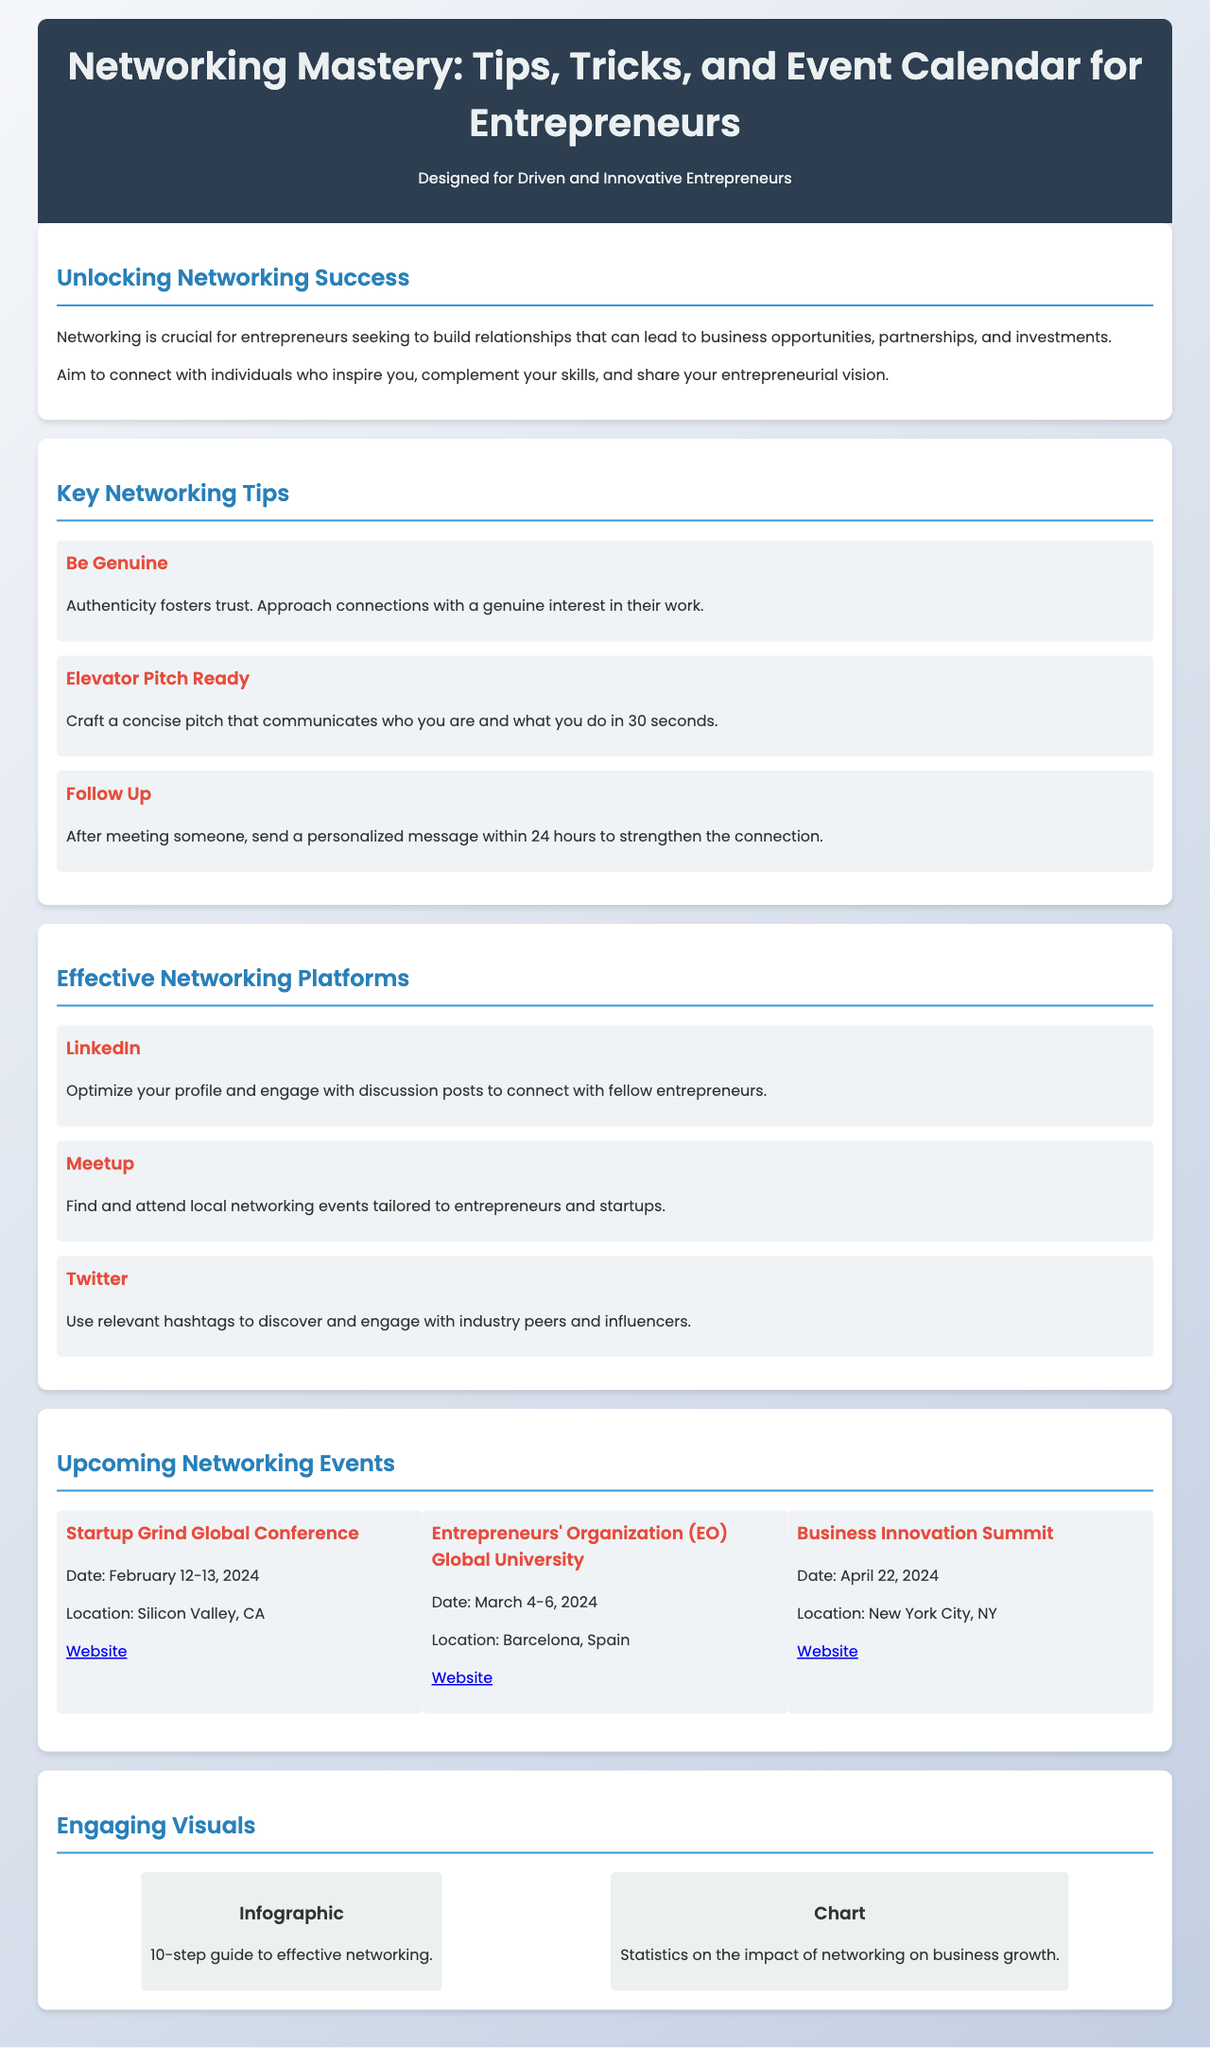What are the three key networking tips mentioned? The document lists three tips under "Key Networking Tips" which are "Be Genuine," "Elevator Pitch Ready," and "Follow Up."
Answer: Be Genuine, Elevator Pitch Ready, Follow Up When is the Startup Grind Global Conference scheduled? The date for the Startup Grind Global Conference is explicitly stated in the document under "Upcoming Networking Events."
Answer: February 12-13, 2024 What is the location of the Entrepreneurs' Organization (EO) Global University event? The document specifies the location of the Entrepreneurs' Organization event in Barcelona, Spain, under the events section.
Answer: Barcelona, Spain Which platform is suggested for optimizing your profile? The document recommends optimizing your profile on LinkedIn in the "Effective Networking Platforms" section.
Answer: LinkedIn What is the date of the Business Innovation Summit? The date for the Business Innovation Summit is clearly presented in the "Upcoming Networking Events" section.
Answer: April 22, 2024 How many visuals are included in the Engaging Visuals section? The document lists two types of visuals in the "Engaging Visuals" section: an infographic and a chart.
Answer: 2 What is the main theme of the brochure? The brochure's title clearly states it focuses on networking mastery for entrepreneurs and enhancing business connections.
Answer: Networking Mastery What color is used for the header background? The background color of the header section is specifically mentioned in the CSS style section.
Answer: #2c3e50 What format should networking messages be sent in after a meeting? The document advises sending personalized messages within 24 hours, indicating a specific format for post-meeting communications.
Answer: Personalized message 